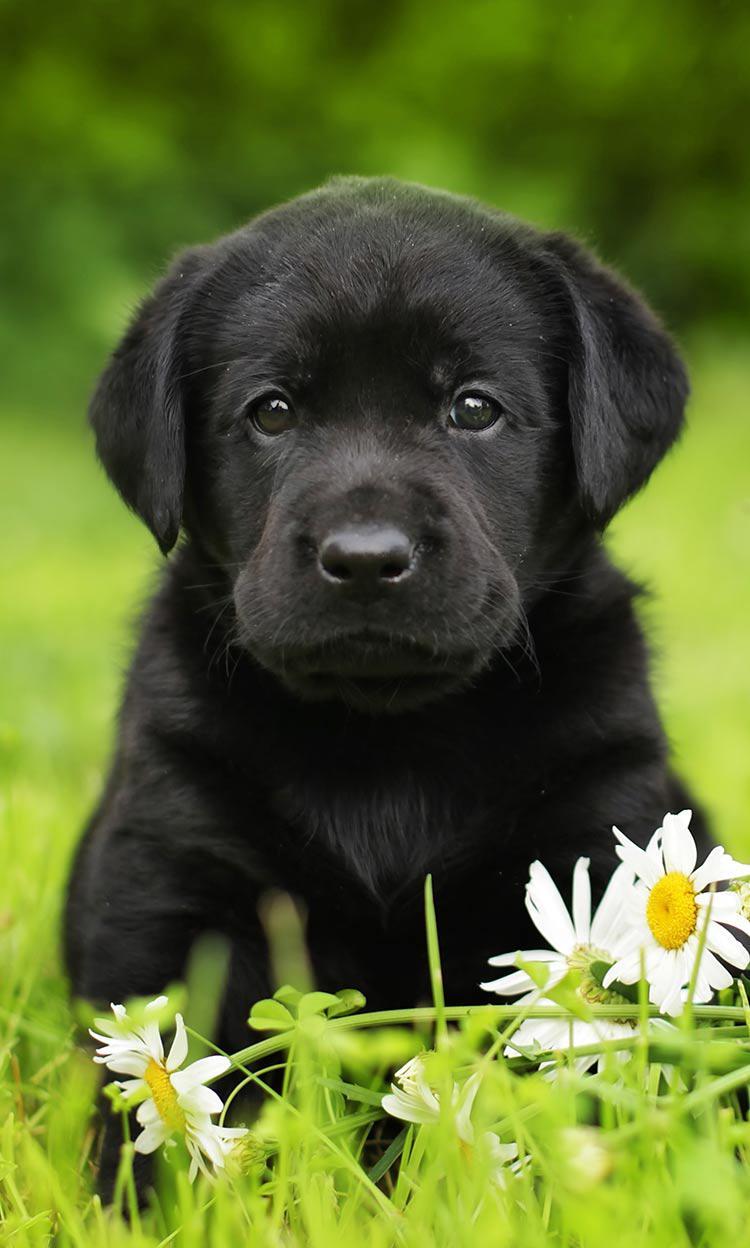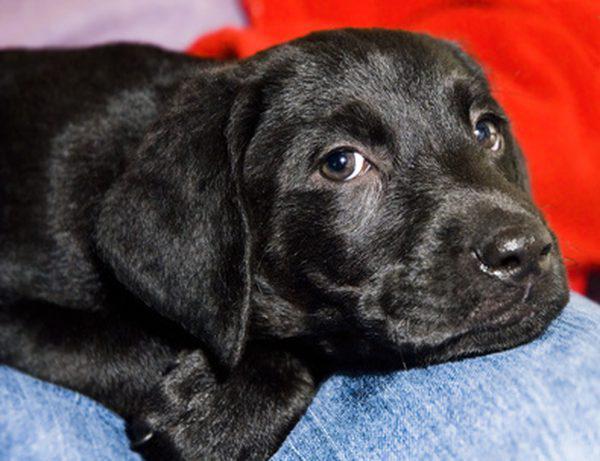The first image is the image on the left, the second image is the image on the right. Evaluate the accuracy of this statement regarding the images: "The left image contains at least two black dogs.". Is it true? Answer yes or no. No. The first image is the image on the left, the second image is the image on the right. For the images shown, is this caption "One image contains at least two all-black lab puppies posed side-by-side outdoors." true? Answer yes or no. No. 